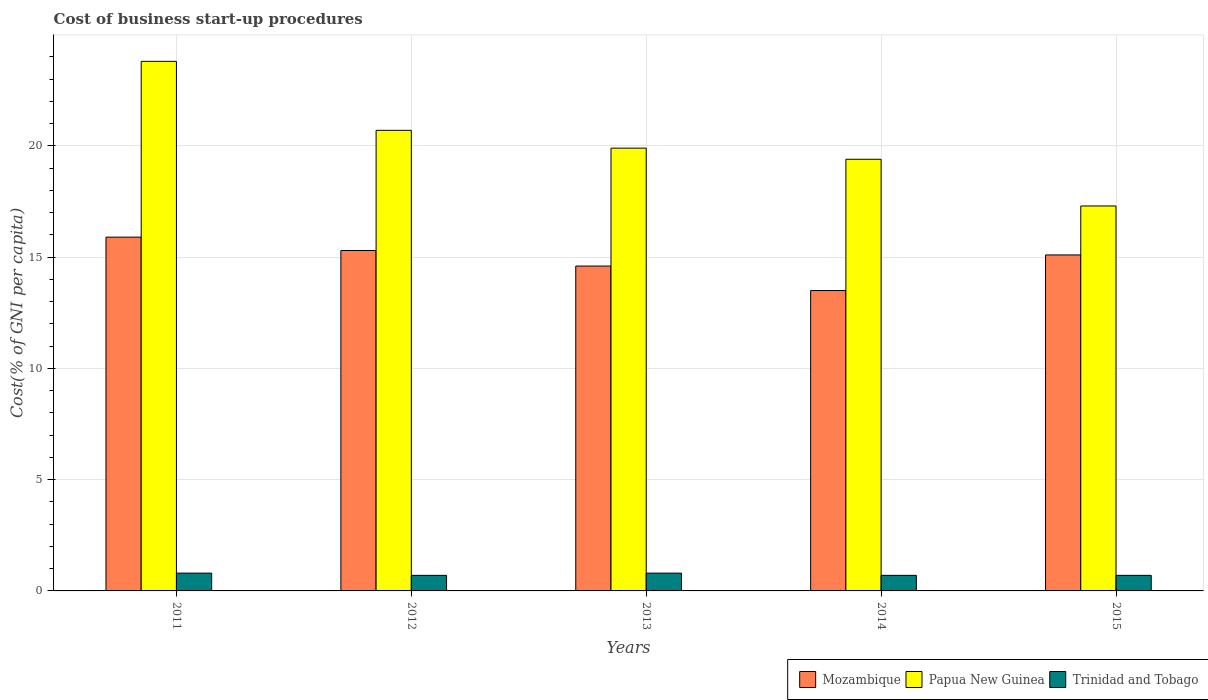Are the number of bars on each tick of the X-axis equal?
Make the answer very short. Yes. How many bars are there on the 4th tick from the right?
Your response must be concise. 3. What is the label of the 2nd group of bars from the left?
Make the answer very short. 2012. In how many cases, is the number of bars for a given year not equal to the number of legend labels?
Keep it short and to the point. 0. What is the cost of business start-up procedures in Papua New Guinea in 2011?
Give a very brief answer. 23.8. Across all years, what is the maximum cost of business start-up procedures in Papua New Guinea?
Offer a very short reply. 23.8. In which year was the cost of business start-up procedures in Mozambique minimum?
Keep it short and to the point. 2014. What is the total cost of business start-up procedures in Trinidad and Tobago in the graph?
Ensure brevity in your answer.  3.7. What is the difference between the cost of business start-up procedures in Papua New Guinea in 2011 and that in 2014?
Give a very brief answer. 4.4. What is the average cost of business start-up procedures in Papua New Guinea per year?
Provide a short and direct response. 20.22. What is the difference between the highest and the second highest cost of business start-up procedures in Mozambique?
Your answer should be very brief. 0.6. What is the difference between the highest and the lowest cost of business start-up procedures in Trinidad and Tobago?
Your answer should be compact. 0.1. In how many years, is the cost of business start-up procedures in Trinidad and Tobago greater than the average cost of business start-up procedures in Trinidad and Tobago taken over all years?
Give a very brief answer. 2. What does the 1st bar from the left in 2011 represents?
Give a very brief answer. Mozambique. What does the 1st bar from the right in 2014 represents?
Offer a terse response. Trinidad and Tobago. Is it the case that in every year, the sum of the cost of business start-up procedures in Papua New Guinea and cost of business start-up procedures in Mozambique is greater than the cost of business start-up procedures in Trinidad and Tobago?
Your answer should be compact. Yes. How many bars are there?
Provide a short and direct response. 15. How many years are there in the graph?
Your answer should be compact. 5. Does the graph contain grids?
Provide a succinct answer. Yes. Where does the legend appear in the graph?
Offer a very short reply. Bottom right. How many legend labels are there?
Your answer should be compact. 3. How are the legend labels stacked?
Make the answer very short. Horizontal. What is the title of the graph?
Your answer should be very brief. Cost of business start-up procedures. What is the label or title of the Y-axis?
Keep it short and to the point. Cost(% of GNI per capita). What is the Cost(% of GNI per capita) in Papua New Guinea in 2011?
Provide a succinct answer. 23.8. What is the Cost(% of GNI per capita) in Papua New Guinea in 2012?
Ensure brevity in your answer.  20.7. What is the Cost(% of GNI per capita) in Trinidad and Tobago in 2012?
Give a very brief answer. 0.7. What is the Cost(% of GNI per capita) of Papua New Guinea in 2013?
Give a very brief answer. 19.9. What is the Cost(% of GNI per capita) in Trinidad and Tobago in 2013?
Make the answer very short. 0.8. What is the Cost(% of GNI per capita) of Mozambique in 2014?
Keep it short and to the point. 13.5. What is the Cost(% of GNI per capita) of Mozambique in 2015?
Provide a short and direct response. 15.1. What is the Cost(% of GNI per capita) of Papua New Guinea in 2015?
Make the answer very short. 17.3. What is the Cost(% of GNI per capita) in Trinidad and Tobago in 2015?
Offer a very short reply. 0.7. Across all years, what is the maximum Cost(% of GNI per capita) in Mozambique?
Offer a terse response. 15.9. Across all years, what is the maximum Cost(% of GNI per capita) in Papua New Guinea?
Give a very brief answer. 23.8. Across all years, what is the maximum Cost(% of GNI per capita) in Trinidad and Tobago?
Ensure brevity in your answer.  0.8. Across all years, what is the minimum Cost(% of GNI per capita) of Trinidad and Tobago?
Offer a terse response. 0.7. What is the total Cost(% of GNI per capita) in Mozambique in the graph?
Your answer should be compact. 74.4. What is the total Cost(% of GNI per capita) in Papua New Guinea in the graph?
Ensure brevity in your answer.  101.1. What is the total Cost(% of GNI per capita) in Trinidad and Tobago in the graph?
Make the answer very short. 3.7. What is the difference between the Cost(% of GNI per capita) of Mozambique in 2011 and that in 2013?
Your response must be concise. 1.3. What is the difference between the Cost(% of GNI per capita) of Papua New Guinea in 2011 and that in 2013?
Your response must be concise. 3.9. What is the difference between the Cost(% of GNI per capita) of Trinidad and Tobago in 2011 and that in 2014?
Give a very brief answer. 0.1. What is the difference between the Cost(% of GNI per capita) in Mozambique in 2011 and that in 2015?
Provide a short and direct response. 0.8. What is the difference between the Cost(% of GNI per capita) in Papua New Guinea in 2011 and that in 2015?
Offer a terse response. 6.5. What is the difference between the Cost(% of GNI per capita) in Trinidad and Tobago in 2011 and that in 2015?
Offer a very short reply. 0.1. What is the difference between the Cost(% of GNI per capita) in Papua New Guinea in 2012 and that in 2013?
Provide a short and direct response. 0.8. What is the difference between the Cost(% of GNI per capita) of Trinidad and Tobago in 2012 and that in 2013?
Your answer should be very brief. -0.1. What is the difference between the Cost(% of GNI per capita) of Mozambique in 2012 and that in 2014?
Your response must be concise. 1.8. What is the difference between the Cost(% of GNI per capita) in Trinidad and Tobago in 2012 and that in 2014?
Your answer should be very brief. 0. What is the difference between the Cost(% of GNI per capita) of Mozambique in 2012 and that in 2015?
Offer a very short reply. 0.2. What is the difference between the Cost(% of GNI per capita) in Mozambique in 2013 and that in 2014?
Give a very brief answer. 1.1. What is the difference between the Cost(% of GNI per capita) of Papua New Guinea in 2013 and that in 2014?
Provide a succinct answer. 0.5. What is the difference between the Cost(% of GNI per capita) of Trinidad and Tobago in 2013 and that in 2014?
Your answer should be very brief. 0.1. What is the difference between the Cost(% of GNI per capita) in Papua New Guinea in 2014 and that in 2015?
Provide a succinct answer. 2.1. What is the difference between the Cost(% of GNI per capita) of Trinidad and Tobago in 2014 and that in 2015?
Your response must be concise. 0. What is the difference between the Cost(% of GNI per capita) of Mozambique in 2011 and the Cost(% of GNI per capita) of Trinidad and Tobago in 2012?
Your answer should be very brief. 15.2. What is the difference between the Cost(% of GNI per capita) of Papua New Guinea in 2011 and the Cost(% of GNI per capita) of Trinidad and Tobago in 2012?
Your response must be concise. 23.1. What is the difference between the Cost(% of GNI per capita) of Mozambique in 2011 and the Cost(% of GNI per capita) of Papua New Guinea in 2013?
Make the answer very short. -4. What is the difference between the Cost(% of GNI per capita) in Mozambique in 2011 and the Cost(% of GNI per capita) in Trinidad and Tobago in 2013?
Offer a terse response. 15.1. What is the difference between the Cost(% of GNI per capita) of Papua New Guinea in 2011 and the Cost(% of GNI per capita) of Trinidad and Tobago in 2013?
Provide a short and direct response. 23. What is the difference between the Cost(% of GNI per capita) in Mozambique in 2011 and the Cost(% of GNI per capita) in Papua New Guinea in 2014?
Keep it short and to the point. -3.5. What is the difference between the Cost(% of GNI per capita) of Papua New Guinea in 2011 and the Cost(% of GNI per capita) of Trinidad and Tobago in 2014?
Your answer should be compact. 23.1. What is the difference between the Cost(% of GNI per capita) of Mozambique in 2011 and the Cost(% of GNI per capita) of Papua New Guinea in 2015?
Your answer should be compact. -1.4. What is the difference between the Cost(% of GNI per capita) in Mozambique in 2011 and the Cost(% of GNI per capita) in Trinidad and Tobago in 2015?
Keep it short and to the point. 15.2. What is the difference between the Cost(% of GNI per capita) in Papua New Guinea in 2011 and the Cost(% of GNI per capita) in Trinidad and Tobago in 2015?
Keep it short and to the point. 23.1. What is the difference between the Cost(% of GNI per capita) in Mozambique in 2012 and the Cost(% of GNI per capita) in Trinidad and Tobago in 2013?
Give a very brief answer. 14.5. What is the difference between the Cost(% of GNI per capita) of Papua New Guinea in 2012 and the Cost(% of GNI per capita) of Trinidad and Tobago in 2013?
Provide a succinct answer. 19.9. What is the difference between the Cost(% of GNI per capita) in Papua New Guinea in 2012 and the Cost(% of GNI per capita) in Trinidad and Tobago in 2014?
Offer a terse response. 20. What is the difference between the Cost(% of GNI per capita) of Papua New Guinea in 2012 and the Cost(% of GNI per capita) of Trinidad and Tobago in 2015?
Make the answer very short. 20. What is the difference between the Cost(% of GNI per capita) in Mozambique in 2013 and the Cost(% of GNI per capita) in Papua New Guinea in 2014?
Your answer should be very brief. -4.8. What is the difference between the Cost(% of GNI per capita) of Mozambique in 2013 and the Cost(% of GNI per capita) of Papua New Guinea in 2015?
Ensure brevity in your answer.  -2.7. What is the difference between the Cost(% of GNI per capita) in Mozambique in 2013 and the Cost(% of GNI per capita) in Trinidad and Tobago in 2015?
Ensure brevity in your answer.  13.9. What is the difference between the Cost(% of GNI per capita) of Mozambique in 2014 and the Cost(% of GNI per capita) of Papua New Guinea in 2015?
Offer a very short reply. -3.8. What is the difference between the Cost(% of GNI per capita) in Mozambique in 2014 and the Cost(% of GNI per capita) in Trinidad and Tobago in 2015?
Ensure brevity in your answer.  12.8. What is the difference between the Cost(% of GNI per capita) in Papua New Guinea in 2014 and the Cost(% of GNI per capita) in Trinidad and Tobago in 2015?
Your answer should be very brief. 18.7. What is the average Cost(% of GNI per capita) in Mozambique per year?
Offer a very short reply. 14.88. What is the average Cost(% of GNI per capita) in Papua New Guinea per year?
Keep it short and to the point. 20.22. What is the average Cost(% of GNI per capita) in Trinidad and Tobago per year?
Ensure brevity in your answer.  0.74. In the year 2011, what is the difference between the Cost(% of GNI per capita) in Papua New Guinea and Cost(% of GNI per capita) in Trinidad and Tobago?
Give a very brief answer. 23. In the year 2012, what is the difference between the Cost(% of GNI per capita) in Mozambique and Cost(% of GNI per capita) in Trinidad and Tobago?
Provide a succinct answer. 14.6. In the year 2012, what is the difference between the Cost(% of GNI per capita) in Papua New Guinea and Cost(% of GNI per capita) in Trinidad and Tobago?
Provide a short and direct response. 20. In the year 2013, what is the difference between the Cost(% of GNI per capita) in Mozambique and Cost(% of GNI per capita) in Trinidad and Tobago?
Provide a short and direct response. 13.8. In the year 2013, what is the difference between the Cost(% of GNI per capita) in Papua New Guinea and Cost(% of GNI per capita) in Trinidad and Tobago?
Your answer should be compact. 19.1. In the year 2014, what is the difference between the Cost(% of GNI per capita) of Papua New Guinea and Cost(% of GNI per capita) of Trinidad and Tobago?
Your answer should be compact. 18.7. In the year 2015, what is the difference between the Cost(% of GNI per capita) in Mozambique and Cost(% of GNI per capita) in Papua New Guinea?
Give a very brief answer. -2.2. In the year 2015, what is the difference between the Cost(% of GNI per capita) in Mozambique and Cost(% of GNI per capita) in Trinidad and Tobago?
Your answer should be compact. 14.4. What is the ratio of the Cost(% of GNI per capita) in Mozambique in 2011 to that in 2012?
Offer a very short reply. 1.04. What is the ratio of the Cost(% of GNI per capita) of Papua New Guinea in 2011 to that in 2012?
Offer a very short reply. 1.15. What is the ratio of the Cost(% of GNI per capita) of Trinidad and Tobago in 2011 to that in 2012?
Provide a short and direct response. 1.14. What is the ratio of the Cost(% of GNI per capita) in Mozambique in 2011 to that in 2013?
Your answer should be compact. 1.09. What is the ratio of the Cost(% of GNI per capita) of Papua New Guinea in 2011 to that in 2013?
Your answer should be very brief. 1.2. What is the ratio of the Cost(% of GNI per capita) of Mozambique in 2011 to that in 2014?
Keep it short and to the point. 1.18. What is the ratio of the Cost(% of GNI per capita) in Papua New Guinea in 2011 to that in 2014?
Ensure brevity in your answer.  1.23. What is the ratio of the Cost(% of GNI per capita) in Trinidad and Tobago in 2011 to that in 2014?
Your response must be concise. 1.14. What is the ratio of the Cost(% of GNI per capita) of Mozambique in 2011 to that in 2015?
Your answer should be compact. 1.05. What is the ratio of the Cost(% of GNI per capita) of Papua New Guinea in 2011 to that in 2015?
Give a very brief answer. 1.38. What is the ratio of the Cost(% of GNI per capita) in Mozambique in 2012 to that in 2013?
Your answer should be very brief. 1.05. What is the ratio of the Cost(% of GNI per capita) in Papua New Guinea in 2012 to that in 2013?
Offer a very short reply. 1.04. What is the ratio of the Cost(% of GNI per capita) in Mozambique in 2012 to that in 2014?
Offer a terse response. 1.13. What is the ratio of the Cost(% of GNI per capita) in Papua New Guinea in 2012 to that in 2014?
Your response must be concise. 1.07. What is the ratio of the Cost(% of GNI per capita) of Trinidad and Tobago in 2012 to that in 2014?
Ensure brevity in your answer.  1. What is the ratio of the Cost(% of GNI per capita) in Mozambique in 2012 to that in 2015?
Keep it short and to the point. 1.01. What is the ratio of the Cost(% of GNI per capita) of Papua New Guinea in 2012 to that in 2015?
Your response must be concise. 1.2. What is the ratio of the Cost(% of GNI per capita) of Mozambique in 2013 to that in 2014?
Give a very brief answer. 1.08. What is the ratio of the Cost(% of GNI per capita) of Papua New Guinea in 2013 to that in 2014?
Provide a succinct answer. 1.03. What is the ratio of the Cost(% of GNI per capita) of Trinidad and Tobago in 2013 to that in 2014?
Make the answer very short. 1.14. What is the ratio of the Cost(% of GNI per capita) in Mozambique in 2013 to that in 2015?
Offer a very short reply. 0.97. What is the ratio of the Cost(% of GNI per capita) of Papua New Guinea in 2013 to that in 2015?
Ensure brevity in your answer.  1.15. What is the ratio of the Cost(% of GNI per capita) of Trinidad and Tobago in 2013 to that in 2015?
Your response must be concise. 1.14. What is the ratio of the Cost(% of GNI per capita) of Mozambique in 2014 to that in 2015?
Make the answer very short. 0.89. What is the ratio of the Cost(% of GNI per capita) of Papua New Guinea in 2014 to that in 2015?
Keep it short and to the point. 1.12. What is the difference between the highest and the second highest Cost(% of GNI per capita) in Mozambique?
Provide a succinct answer. 0.6. What is the difference between the highest and the second highest Cost(% of GNI per capita) of Trinidad and Tobago?
Offer a terse response. 0. What is the difference between the highest and the lowest Cost(% of GNI per capita) of Papua New Guinea?
Give a very brief answer. 6.5. 